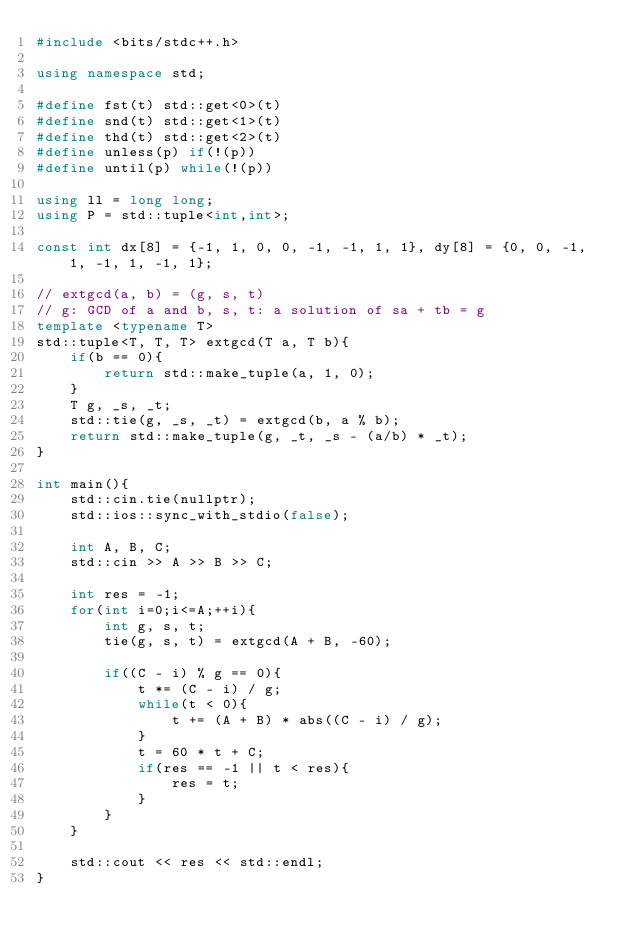Convert code to text. <code><loc_0><loc_0><loc_500><loc_500><_C++_>#include <bits/stdc++.h>

using namespace std;

#define fst(t) std::get<0>(t)
#define snd(t) std::get<1>(t)
#define thd(t) std::get<2>(t)
#define unless(p) if(!(p))
#define until(p) while(!(p))

using ll = long long;
using P = std::tuple<int,int>;

const int dx[8] = {-1, 1, 0, 0, -1, -1, 1, 1}, dy[8] = {0, 0, -1, 1, -1, 1, -1, 1};

// extgcd(a, b) = (g, s, t)
// g: GCD of a and b, s, t: a solution of sa + tb = g
template <typename T>
std::tuple<T, T, T> extgcd(T a, T b){
    if(b == 0){
        return std::make_tuple(a, 1, 0);
    }
    T g, _s, _t;
    std::tie(g, _s, _t) = extgcd(b, a % b);
    return std::make_tuple(g, _t, _s - (a/b) * _t);
}

int main(){
    std::cin.tie(nullptr);
    std::ios::sync_with_stdio(false);

    int A, B, C;
    std::cin >> A >> B >> C;

    int res = -1;
    for(int i=0;i<=A;++i){
        int g, s, t;
        tie(g, s, t) = extgcd(A + B, -60);
        
        if((C - i) % g == 0){
            t *= (C - i) / g;
            while(t < 0){
                t += (A + B) * abs((C - i) / g);
            }
            t = 60 * t + C;
            if(res == -1 || t < res){
                res = t;
            }
        }   
    }

    std::cout << res << std::endl;
}

</code> 